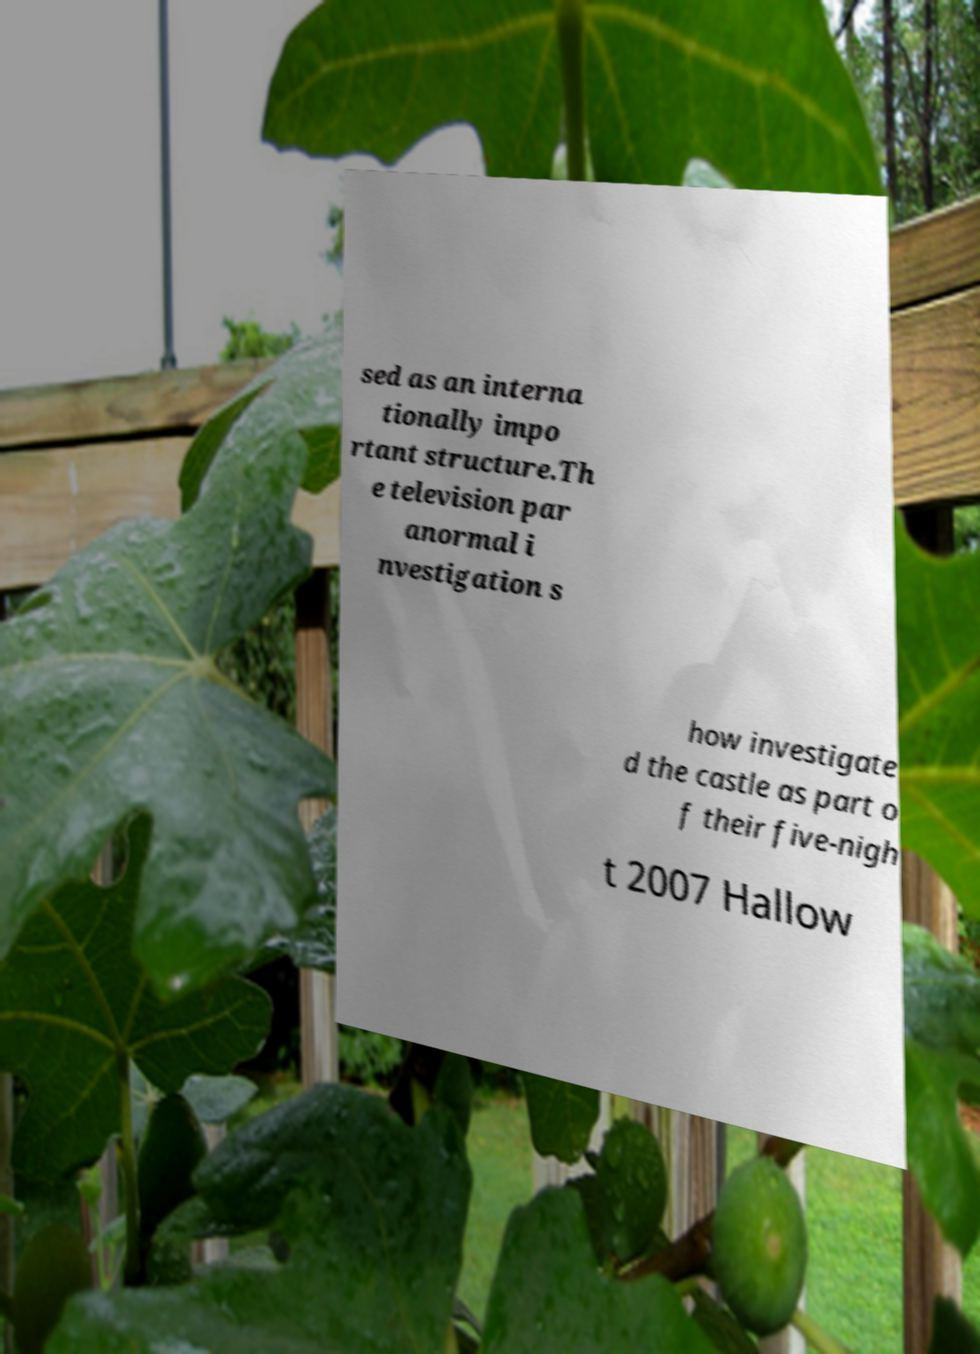Can you read and provide the text displayed in the image?This photo seems to have some interesting text. Can you extract and type it out for me? sed as an interna tionally impo rtant structure.Th e television par anormal i nvestigation s how investigate d the castle as part o f their five-nigh t 2007 Hallow 